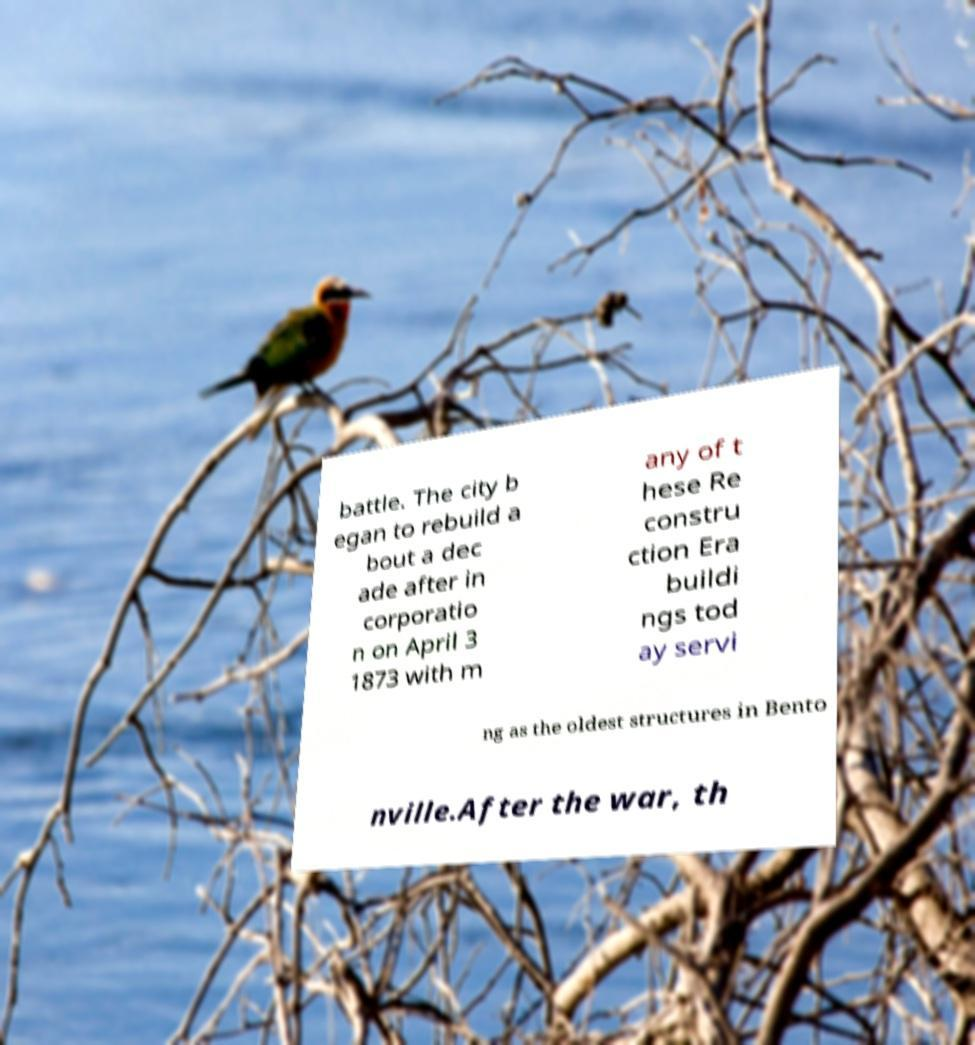Can you accurately transcribe the text from the provided image for me? battle. The city b egan to rebuild a bout a dec ade after in corporatio n on April 3 1873 with m any of t hese Re constru ction Era buildi ngs tod ay servi ng as the oldest structures in Bento nville.After the war, th 